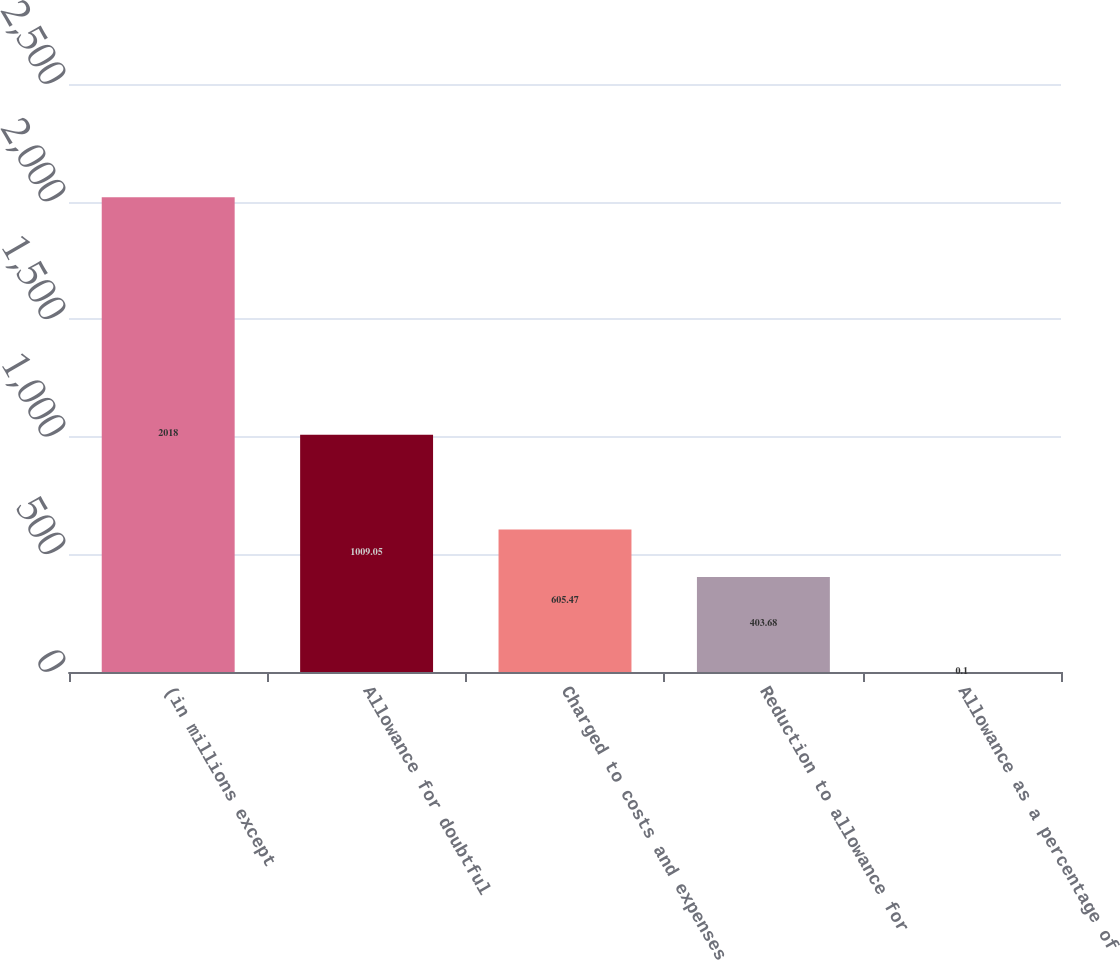<chart> <loc_0><loc_0><loc_500><loc_500><bar_chart><fcel>(in millions except<fcel>Allowance for doubtful<fcel>Charged to costs and expenses<fcel>Reduction to allowance for<fcel>Allowance as a percentage of<nl><fcel>2018<fcel>1009.05<fcel>605.47<fcel>403.68<fcel>0.1<nl></chart> 